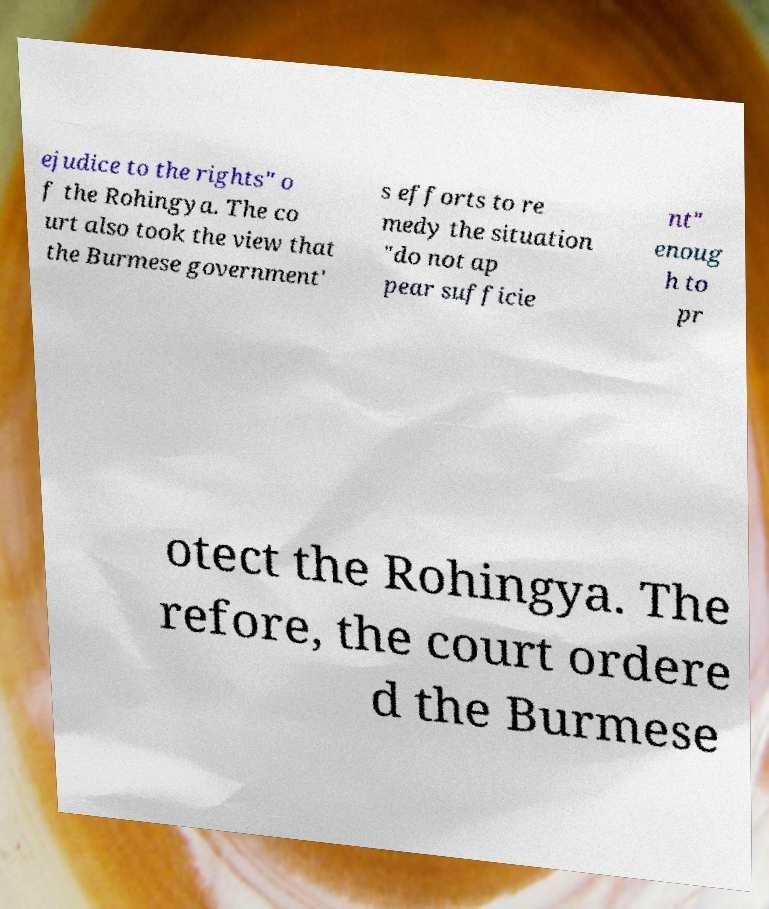There's text embedded in this image that I need extracted. Can you transcribe it verbatim? ejudice to the rights" o f the Rohingya. The co urt also took the view that the Burmese government' s efforts to re medy the situation "do not ap pear sufficie nt" enoug h to pr otect the Rohingya. The refore, the court ordere d the Burmese 